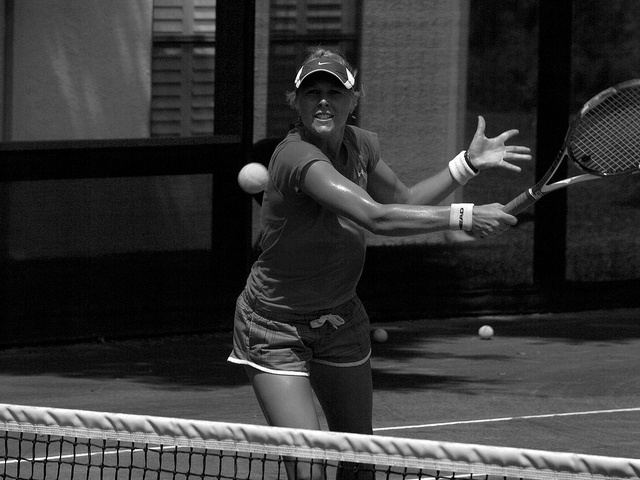Describe the objects in this image and their specific colors. I can see people in black, gray, darkgray, and lightgray tones, tennis racket in black, gray, darkgray, and lightgray tones, sports ball in black, gray, darkgray, and lightgray tones, sports ball in black, darkgray, gray, and lightgray tones, and sports ball in gray and black tones in this image. 